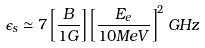<formula> <loc_0><loc_0><loc_500><loc_500>\epsilon _ { s } \simeq 7 \left [ \frac { B } { 1 G } \right ] \left [ \frac { E _ { e } } { 1 0 M e V } \right ] ^ { 2 } G H z</formula> 